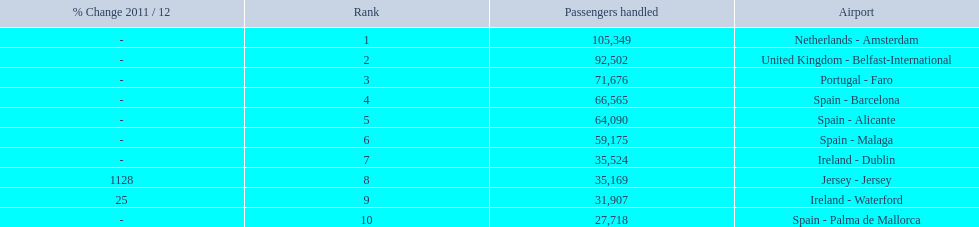Give me the full table as a dictionary. {'header': ['% Change 2011 / 12', 'Rank', 'Passengers handled', 'Airport'], 'rows': [['-', '1', '105,349', 'Netherlands - Amsterdam'], ['-', '2', '92,502', 'United Kingdom - Belfast-International'], ['-', '3', '71,676', 'Portugal - Faro'], ['-', '4', '66,565', 'Spain - Barcelona'], ['-', '5', '64,090', 'Spain - Alicante'], ['-', '6', '59,175', 'Spain - Malaga'], ['-', '7', '35,524', 'Ireland - Dublin'], ['1128', '8', '35,169', 'Jersey - Jersey'], ['25', '9', '31,907', 'Ireland - Waterford'], ['-', '10', '27,718', 'Spain - Palma de Mallorca']]} What are all the passengers handled values for london southend airport? 105,349, 92,502, 71,676, 66,565, 64,090, 59,175, 35,524, 35,169, 31,907, 27,718. Which are 30,000 or less? 27,718. What airport is this for? Spain - Palma de Mallorca. 